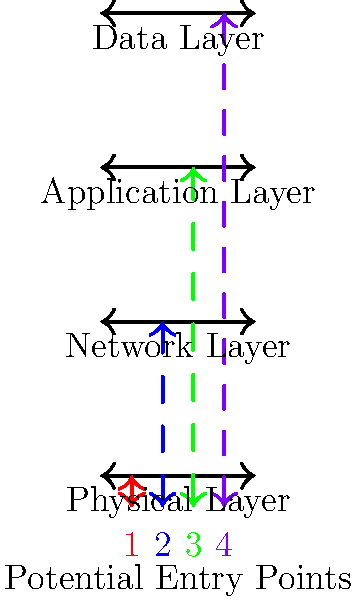In the multi-layered security model illustration, which numbered entry point represents the most direct path to potentially sensitive data, and why is this considered a significant vulnerability? To answer this question, let's analyze each potential entry point in the multi-layered security model:

1. Physical Layer (Red, #1): This represents physical access to systems, which can be a severe threat but typically requires on-site presence.

2. Network Layer (Blue, #2): This involves network-based attacks, which can be executed remotely but still need to traverse multiple layers.

3. Application Layer (Green, #3): This targets vulnerabilities in software applications, which are closer to the data but still have some protections.

4. Data Layer (Purple, #4): This represents direct access to the data storage layer, which is the closest to the sensitive information.

The most direct path to potentially sensitive data is entry point #4 (Purple), which targets the Data Layer. This is considered a significant vulnerability for several reasons:

1. Proximity to data: It bypasses other security layers, potentially providing direct access to sensitive information.

2. Reduced security measures: Other layers may have additional security controls that are bypassed at this level.

3. High impact: Successful attacks at this layer can lead to data breaches, unauthorized data manipulation, or data exfiltration.

4. Difficulty in detection: Attacks at this level might not trigger alerts in other security layers, making them harder to detect.

5. Potential for widespread damage: Access at the data layer could affect multiple applications or systems that rely on the same data store.

As a cyber security expert focusing on software vulnerabilities, it's crucial to understand that while all layers need protection, vulnerabilities that allow direct access to the data layer are particularly critical and require special attention in security assessments and mitigation strategies.
Answer: Entry point #4 (Data Layer) 